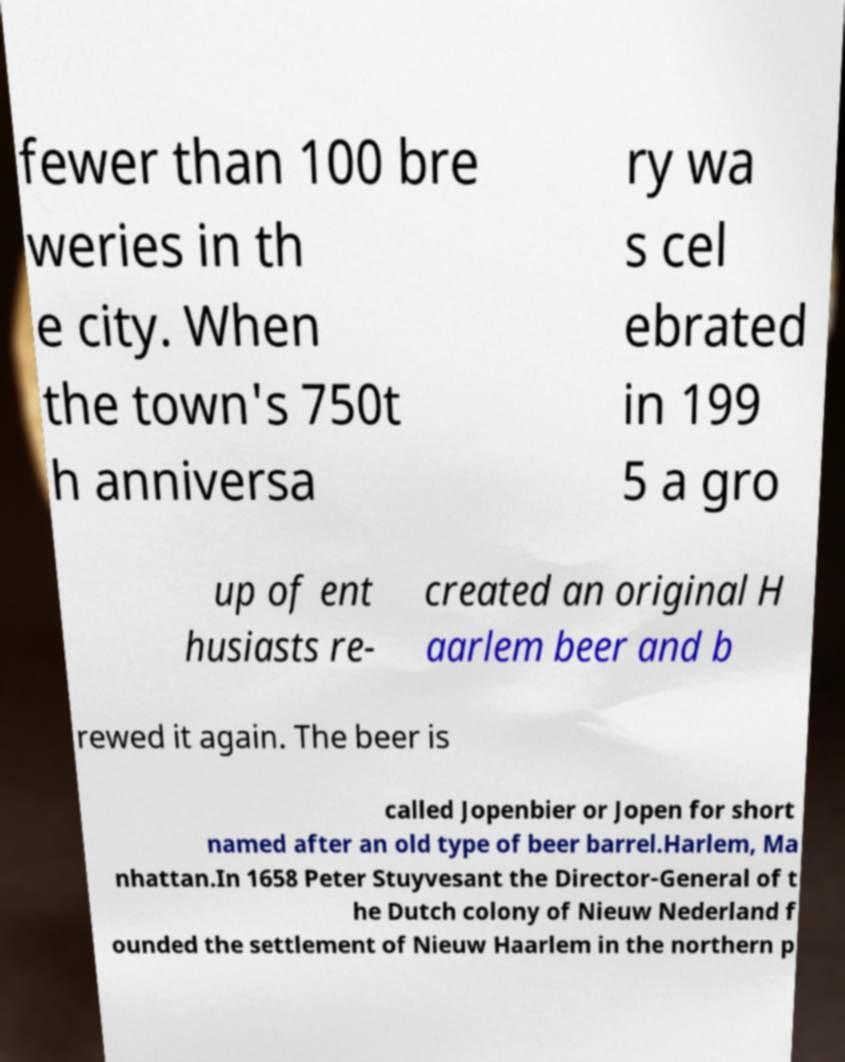For documentation purposes, I need the text within this image transcribed. Could you provide that? fewer than 100 bre weries in th e city. When the town's 750t h anniversa ry wa s cel ebrated in 199 5 a gro up of ent husiasts re- created an original H aarlem beer and b rewed it again. The beer is called Jopenbier or Jopen for short named after an old type of beer barrel.Harlem, Ma nhattan.In 1658 Peter Stuyvesant the Director-General of t he Dutch colony of Nieuw Nederland f ounded the settlement of Nieuw Haarlem in the northern p 